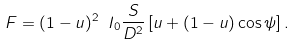Convert formula to latex. <formula><loc_0><loc_0><loc_500><loc_500>F = ( 1 - u ) ^ { 2 } \ I _ { 0 } \frac { S } { D ^ { 2 } } \left [ u + ( 1 - u ) \cos { \psi } \right ] .</formula> 